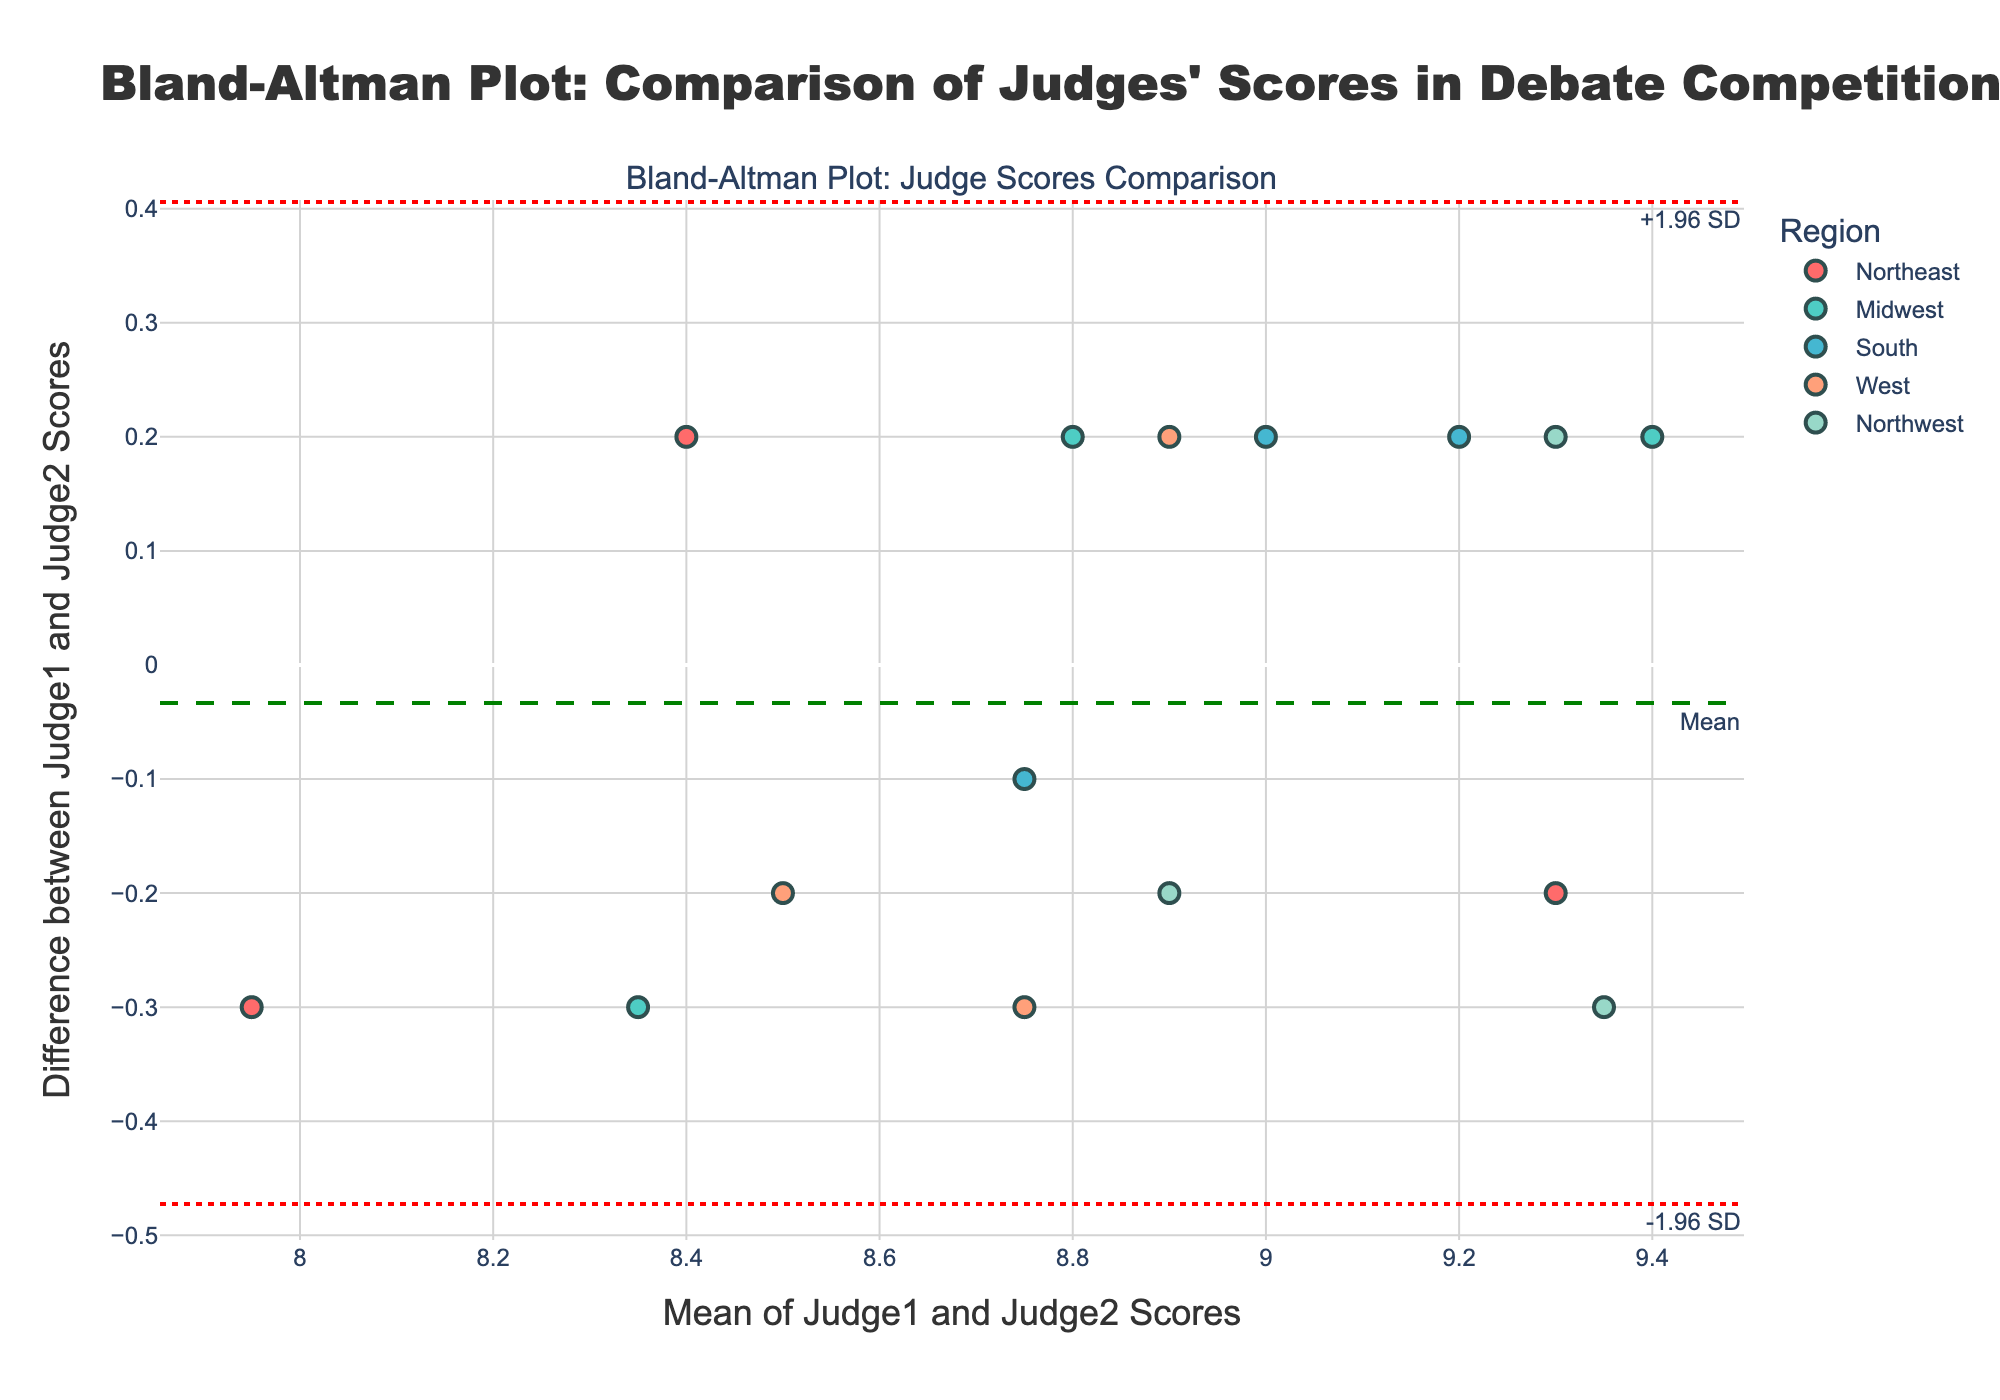What is the title of the plot? The title can be seen at the top of the plot, highlighted in a larger, bold font. The title reads, "Bland-Altman Plot: Comparison of Judges' Scores in Debate Competitions".
Answer: Bland-Altman Plot: Comparison of Judges' Scores in Debate Competitions What regions are represented by the different colors? The plot legend indicates that different regions are represented by different colors. 'Northeast' is in red, 'Midwest' is in teal, 'South' is in blue, 'West' is in light orange, and 'Northwest' is in light green.
Answer: Northeast, Midwest, South, West, Northwest How many data points are there for the Northeast region? By observing the red markers on the plot, we count the number of red points representing the Northeast region. There are three red data points.
Answer: 3 What is the approximate mean difference between Judge1 and Judge2 scores? The mean difference is represented by the dashed green horizontal line. This line appears close to 0.02 on the y-axis.
Answer: 0.02 What are the limits of agreement for the judges' scores? The limits of agreement are represented by the dotted red horizontal lines. The upper limit ( +1.96 SD) is around 0.60 and the lower limit (-1.96 SD) is around -0.56.
Answer: 0.60 and -0.56 Which region shows the largest difference between Judge1 and Judge2 scores, and what is the value of this difference? By identifying data points that are farthest from the mean difference line, we notice the maximum difference is a teal point (Midwest) around 0.6 on the y-axis.
Answer: Midwest, 0.6 Are there more data points above or below the mean difference line? A general count of data points above and below the green dashed line shows that there are more points above (9) the line than below (6).
Answer: Above Do any regions have data points that fall outside the limits of agreement? Observing the plot, none of the data points fall outside the dotted red lines, indicating all points are within the limits of agreement.
Answer: No What is the mean of the scores given by Judges 1 and 2 for the highest discrepancy in the scores from the South region? Identify the blue (South) data point with the highest discrepancy, which is located around -0.2 on the y-axis. The corresponding mean score on the x-axis is approximately 9.2.
Answer: 9.2 How close is the mean difference to zero, and what does it imply about the judges' scoring? The mean difference, represented by the green dashed line, is close to 0 (about 0.02). This implies that, on average, the scores given by Judge1 and Judge2 are almost identical.
Answer: Very close, implies near-identical scoring 